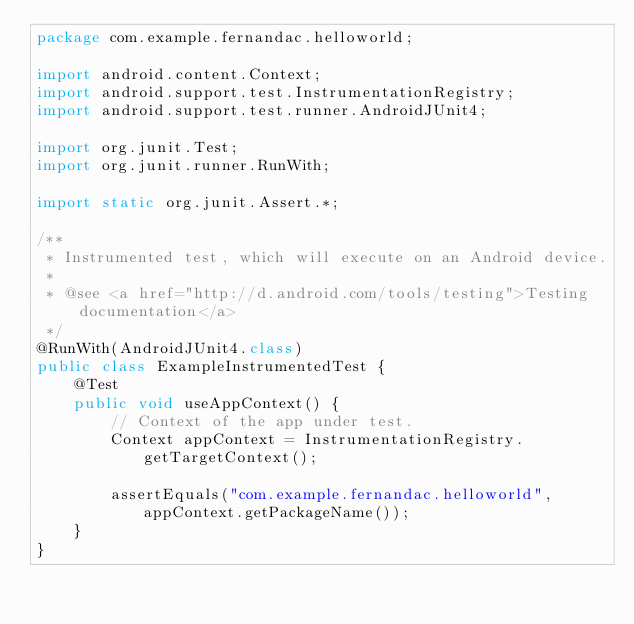Convert code to text. <code><loc_0><loc_0><loc_500><loc_500><_Java_>package com.example.fernandac.helloworld;

import android.content.Context;
import android.support.test.InstrumentationRegistry;
import android.support.test.runner.AndroidJUnit4;

import org.junit.Test;
import org.junit.runner.RunWith;

import static org.junit.Assert.*;

/**
 * Instrumented test, which will execute on an Android device.
 *
 * @see <a href="http://d.android.com/tools/testing">Testing documentation</a>
 */
@RunWith(AndroidJUnit4.class)
public class ExampleInstrumentedTest {
    @Test
    public void useAppContext() {
        // Context of the app under test.
        Context appContext = InstrumentationRegistry.getTargetContext();

        assertEquals("com.example.fernandac.helloworld", appContext.getPackageName());
    }
}
</code> 